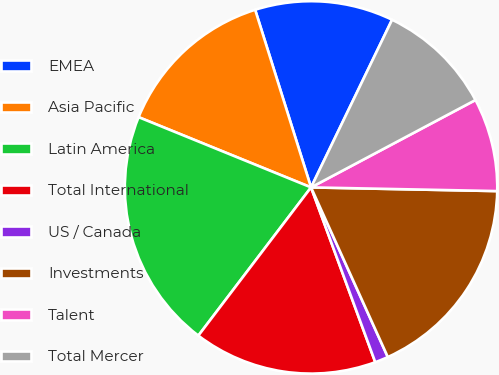Convert chart to OTSL. <chart><loc_0><loc_0><loc_500><loc_500><pie_chart><fcel>EMEA<fcel>Asia Pacific<fcel>Latin America<fcel>Total International<fcel>US / Canada<fcel>Investments<fcel>Talent<fcel>Total Mercer<nl><fcel>12.02%<fcel>13.99%<fcel>20.81%<fcel>15.95%<fcel>1.16%<fcel>17.92%<fcel>8.09%<fcel>10.06%<nl></chart> 